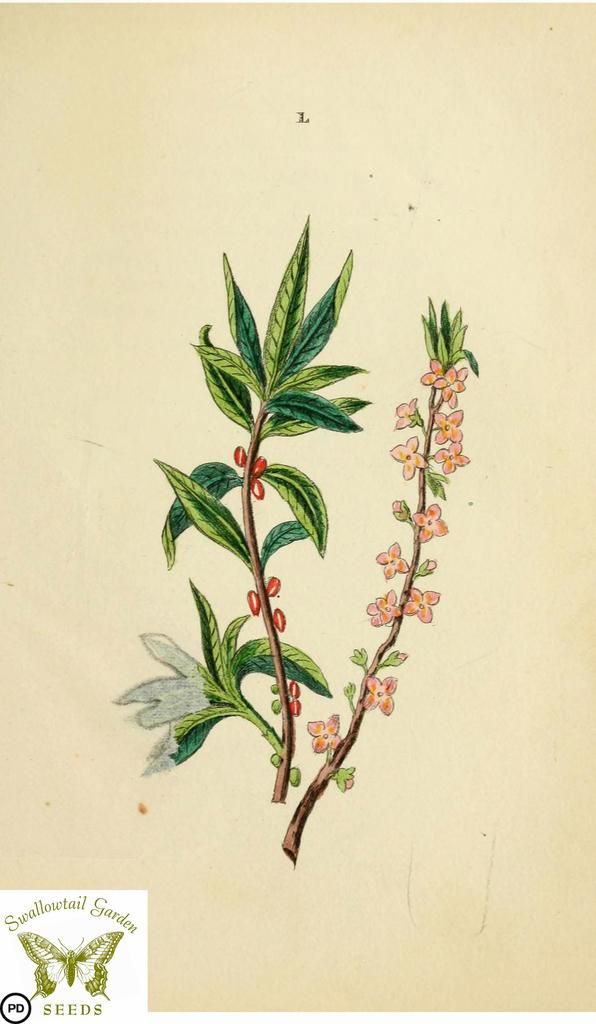What is the main subject of the image? The main subject of the image is a depiction of plants. Can you describe any additional features of the image? Yes, there is a watermark in the bottom left corner of the image. How does the cushion affect the growth of the plants in the image? There is no cushion present in the image, so it cannot affect the growth of the plants. 